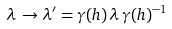Convert formula to latex. <formula><loc_0><loc_0><loc_500><loc_500>\lambda \, \rightarrow \lambda ^ { \prime } = \gamma ( h ) \, \lambda \, \gamma ( h ) ^ { - 1 }</formula> 